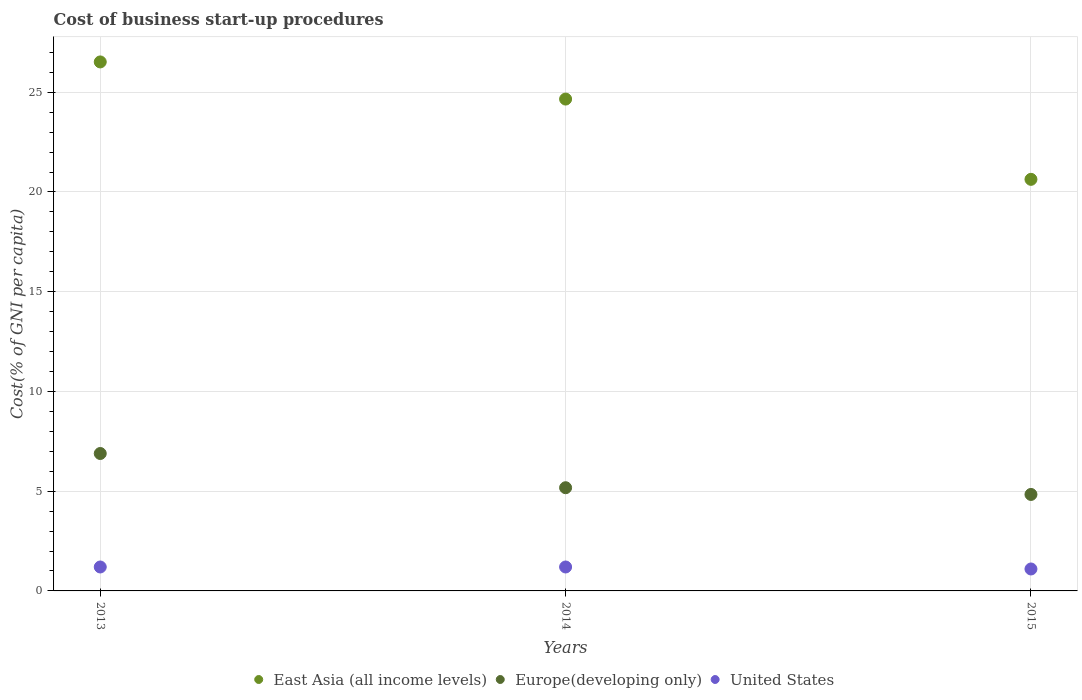How many different coloured dotlines are there?
Your response must be concise. 3. What is the cost of business start-up procedures in East Asia (all income levels) in 2013?
Provide a short and direct response. 26.52. Across all years, what is the maximum cost of business start-up procedures in Europe(developing only)?
Your answer should be compact. 6.89. Across all years, what is the minimum cost of business start-up procedures in United States?
Provide a short and direct response. 1.1. In which year was the cost of business start-up procedures in East Asia (all income levels) maximum?
Make the answer very short. 2013. In which year was the cost of business start-up procedures in United States minimum?
Offer a very short reply. 2015. What is the total cost of business start-up procedures in Europe(developing only) in the graph?
Give a very brief answer. 16.9. What is the difference between the cost of business start-up procedures in East Asia (all income levels) in 2013 and that in 2015?
Your answer should be compact. 5.89. What is the difference between the cost of business start-up procedures in Europe(developing only) in 2015 and the cost of business start-up procedures in United States in 2014?
Offer a terse response. 3.64. What is the average cost of business start-up procedures in East Asia (all income levels) per year?
Offer a terse response. 23.94. In the year 2015, what is the difference between the cost of business start-up procedures in East Asia (all income levels) and cost of business start-up procedures in Europe(developing only)?
Provide a short and direct response. 15.8. What is the ratio of the cost of business start-up procedures in United States in 2013 to that in 2015?
Give a very brief answer. 1.09. What is the difference between the highest and the second highest cost of business start-up procedures in United States?
Your answer should be compact. 0. What is the difference between the highest and the lowest cost of business start-up procedures in East Asia (all income levels)?
Your answer should be very brief. 5.89. Is it the case that in every year, the sum of the cost of business start-up procedures in United States and cost of business start-up procedures in East Asia (all income levels)  is greater than the cost of business start-up procedures in Europe(developing only)?
Your response must be concise. Yes. What is the difference between two consecutive major ticks on the Y-axis?
Give a very brief answer. 5. Does the graph contain grids?
Offer a very short reply. Yes. How many legend labels are there?
Provide a short and direct response. 3. What is the title of the graph?
Make the answer very short. Cost of business start-up procedures. What is the label or title of the Y-axis?
Your response must be concise. Cost(% of GNI per capita). What is the Cost(% of GNI per capita) in East Asia (all income levels) in 2013?
Ensure brevity in your answer.  26.52. What is the Cost(% of GNI per capita) in Europe(developing only) in 2013?
Your answer should be very brief. 6.89. What is the Cost(% of GNI per capita) of United States in 2013?
Provide a succinct answer. 1.2. What is the Cost(% of GNI per capita) of East Asia (all income levels) in 2014?
Your answer should be very brief. 24.66. What is the Cost(% of GNI per capita) in Europe(developing only) in 2014?
Your answer should be very brief. 5.17. What is the Cost(% of GNI per capita) of East Asia (all income levels) in 2015?
Keep it short and to the point. 20.63. What is the Cost(% of GNI per capita) of Europe(developing only) in 2015?
Offer a terse response. 4.84. Across all years, what is the maximum Cost(% of GNI per capita) in East Asia (all income levels)?
Your response must be concise. 26.52. Across all years, what is the maximum Cost(% of GNI per capita) of Europe(developing only)?
Offer a terse response. 6.89. Across all years, what is the maximum Cost(% of GNI per capita) in United States?
Give a very brief answer. 1.2. Across all years, what is the minimum Cost(% of GNI per capita) in East Asia (all income levels)?
Provide a succinct answer. 20.63. Across all years, what is the minimum Cost(% of GNI per capita) in Europe(developing only)?
Offer a very short reply. 4.84. Across all years, what is the minimum Cost(% of GNI per capita) of United States?
Keep it short and to the point. 1.1. What is the total Cost(% of GNI per capita) of East Asia (all income levels) in the graph?
Provide a short and direct response. 71.81. What is the total Cost(% of GNI per capita) in Europe(developing only) in the graph?
Your answer should be compact. 16.9. What is the total Cost(% of GNI per capita) in United States in the graph?
Offer a very short reply. 3.5. What is the difference between the Cost(% of GNI per capita) of East Asia (all income levels) in 2013 and that in 2014?
Your response must be concise. 1.86. What is the difference between the Cost(% of GNI per capita) in Europe(developing only) in 2013 and that in 2014?
Provide a succinct answer. 1.72. What is the difference between the Cost(% of GNI per capita) of United States in 2013 and that in 2014?
Give a very brief answer. 0. What is the difference between the Cost(% of GNI per capita) in East Asia (all income levels) in 2013 and that in 2015?
Provide a succinct answer. 5.89. What is the difference between the Cost(% of GNI per capita) in Europe(developing only) in 2013 and that in 2015?
Give a very brief answer. 2.05. What is the difference between the Cost(% of GNI per capita) of East Asia (all income levels) in 2014 and that in 2015?
Provide a short and direct response. 4.02. What is the difference between the Cost(% of GNI per capita) of Europe(developing only) in 2014 and that in 2015?
Your answer should be very brief. 0.34. What is the difference between the Cost(% of GNI per capita) of United States in 2014 and that in 2015?
Offer a terse response. 0.1. What is the difference between the Cost(% of GNI per capita) in East Asia (all income levels) in 2013 and the Cost(% of GNI per capita) in Europe(developing only) in 2014?
Offer a terse response. 21.35. What is the difference between the Cost(% of GNI per capita) of East Asia (all income levels) in 2013 and the Cost(% of GNI per capita) of United States in 2014?
Provide a succinct answer. 25.32. What is the difference between the Cost(% of GNI per capita) of Europe(developing only) in 2013 and the Cost(% of GNI per capita) of United States in 2014?
Your answer should be compact. 5.69. What is the difference between the Cost(% of GNI per capita) in East Asia (all income levels) in 2013 and the Cost(% of GNI per capita) in Europe(developing only) in 2015?
Your answer should be very brief. 21.68. What is the difference between the Cost(% of GNI per capita) in East Asia (all income levels) in 2013 and the Cost(% of GNI per capita) in United States in 2015?
Ensure brevity in your answer.  25.42. What is the difference between the Cost(% of GNI per capita) in Europe(developing only) in 2013 and the Cost(% of GNI per capita) in United States in 2015?
Make the answer very short. 5.79. What is the difference between the Cost(% of GNI per capita) in East Asia (all income levels) in 2014 and the Cost(% of GNI per capita) in Europe(developing only) in 2015?
Your answer should be very brief. 19.82. What is the difference between the Cost(% of GNI per capita) in East Asia (all income levels) in 2014 and the Cost(% of GNI per capita) in United States in 2015?
Your response must be concise. 23.56. What is the difference between the Cost(% of GNI per capita) of Europe(developing only) in 2014 and the Cost(% of GNI per capita) of United States in 2015?
Your response must be concise. 4.07. What is the average Cost(% of GNI per capita) of East Asia (all income levels) per year?
Give a very brief answer. 23.94. What is the average Cost(% of GNI per capita) of Europe(developing only) per year?
Provide a succinct answer. 5.63. In the year 2013, what is the difference between the Cost(% of GNI per capita) in East Asia (all income levels) and Cost(% of GNI per capita) in Europe(developing only)?
Provide a short and direct response. 19.63. In the year 2013, what is the difference between the Cost(% of GNI per capita) of East Asia (all income levels) and Cost(% of GNI per capita) of United States?
Offer a very short reply. 25.32. In the year 2013, what is the difference between the Cost(% of GNI per capita) of Europe(developing only) and Cost(% of GNI per capita) of United States?
Your answer should be compact. 5.69. In the year 2014, what is the difference between the Cost(% of GNI per capita) of East Asia (all income levels) and Cost(% of GNI per capita) of Europe(developing only)?
Your response must be concise. 19.48. In the year 2014, what is the difference between the Cost(% of GNI per capita) of East Asia (all income levels) and Cost(% of GNI per capita) of United States?
Your answer should be compact. 23.46. In the year 2014, what is the difference between the Cost(% of GNI per capita) of Europe(developing only) and Cost(% of GNI per capita) of United States?
Provide a short and direct response. 3.97. In the year 2015, what is the difference between the Cost(% of GNI per capita) of East Asia (all income levels) and Cost(% of GNI per capita) of Europe(developing only)?
Provide a short and direct response. 15.8. In the year 2015, what is the difference between the Cost(% of GNI per capita) in East Asia (all income levels) and Cost(% of GNI per capita) in United States?
Ensure brevity in your answer.  19.53. In the year 2015, what is the difference between the Cost(% of GNI per capita) of Europe(developing only) and Cost(% of GNI per capita) of United States?
Keep it short and to the point. 3.74. What is the ratio of the Cost(% of GNI per capita) in East Asia (all income levels) in 2013 to that in 2014?
Ensure brevity in your answer.  1.08. What is the ratio of the Cost(% of GNI per capita) in Europe(developing only) in 2013 to that in 2014?
Your answer should be very brief. 1.33. What is the ratio of the Cost(% of GNI per capita) in East Asia (all income levels) in 2013 to that in 2015?
Offer a terse response. 1.29. What is the ratio of the Cost(% of GNI per capita) in Europe(developing only) in 2013 to that in 2015?
Offer a terse response. 1.42. What is the ratio of the Cost(% of GNI per capita) of United States in 2013 to that in 2015?
Ensure brevity in your answer.  1.09. What is the ratio of the Cost(% of GNI per capita) in East Asia (all income levels) in 2014 to that in 2015?
Ensure brevity in your answer.  1.2. What is the ratio of the Cost(% of GNI per capita) in Europe(developing only) in 2014 to that in 2015?
Offer a terse response. 1.07. What is the difference between the highest and the second highest Cost(% of GNI per capita) in East Asia (all income levels)?
Keep it short and to the point. 1.86. What is the difference between the highest and the second highest Cost(% of GNI per capita) of Europe(developing only)?
Provide a short and direct response. 1.72. What is the difference between the highest and the second highest Cost(% of GNI per capita) of United States?
Give a very brief answer. 0. What is the difference between the highest and the lowest Cost(% of GNI per capita) in East Asia (all income levels)?
Your answer should be compact. 5.89. What is the difference between the highest and the lowest Cost(% of GNI per capita) of Europe(developing only)?
Your answer should be compact. 2.05. What is the difference between the highest and the lowest Cost(% of GNI per capita) of United States?
Offer a very short reply. 0.1. 